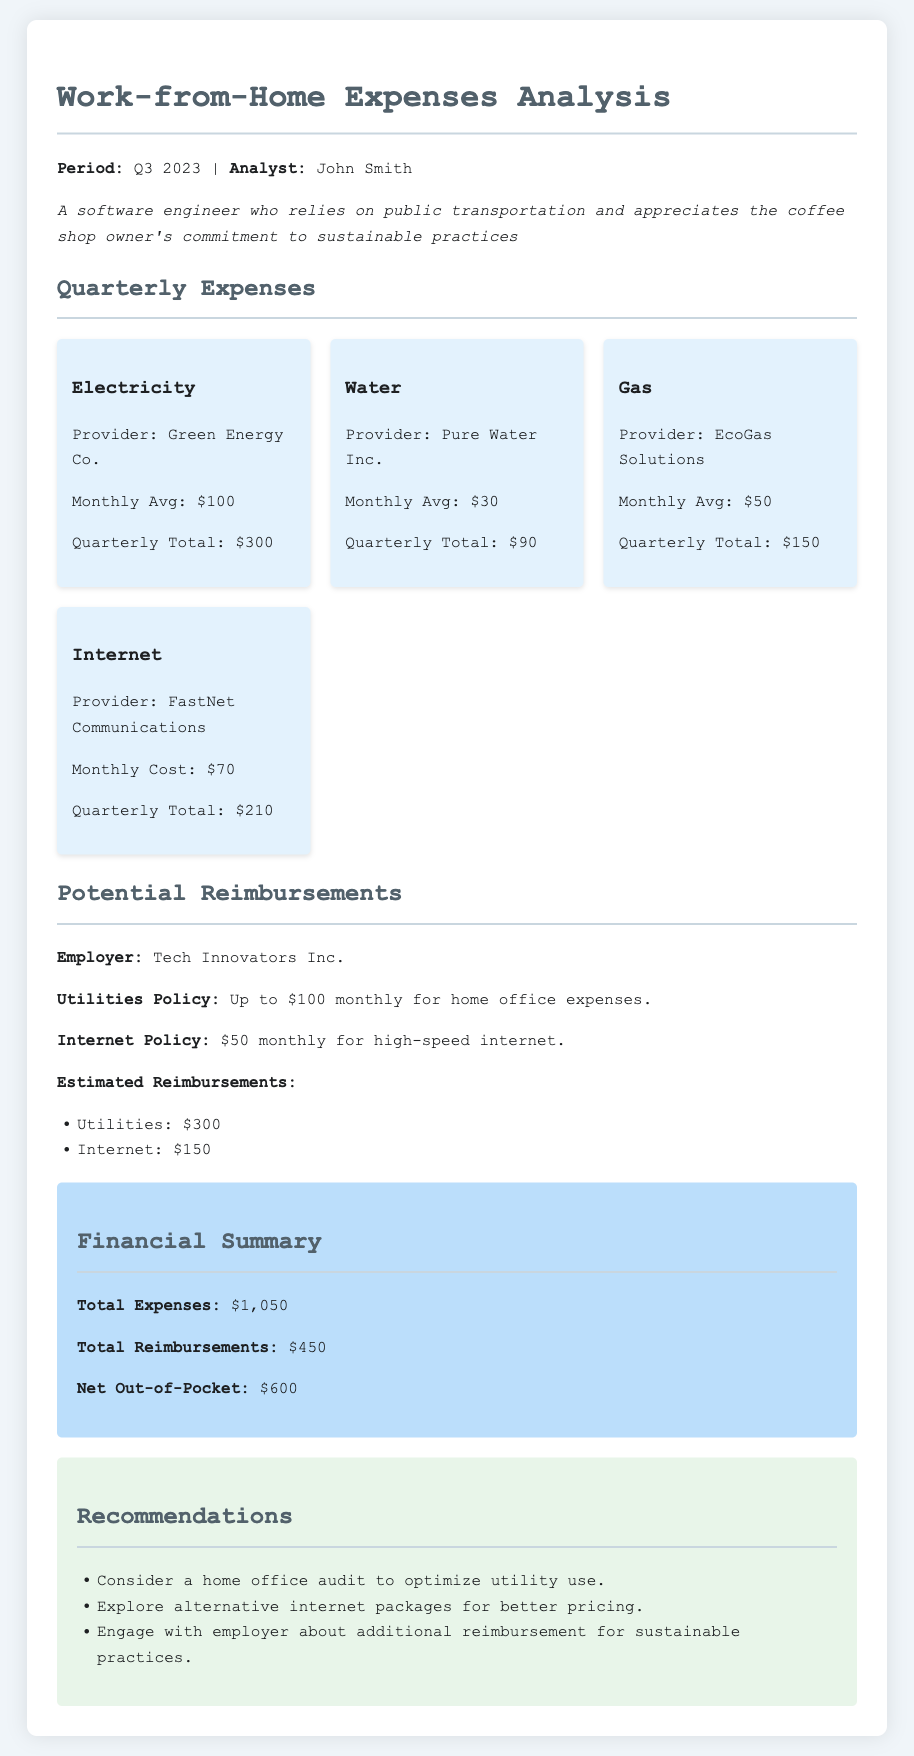What is the total quarterly electricity expense? The total quarterly electricity expense is given in the document as $300.
Answer: $300 Who is the internet provider? The document states that the internet provider is FastNet Communications.
Answer: FastNet Communications What is the estimated reimbursement for utilities? The document specifies the estimated reimbursement for utilities as $300.
Answer: $300 What is the total out-of-pocket expense? The net out-of-pocket expense is calculated as total expenses minus total reimbursements, which is $1,050 - $450 = $600.
Answer: $600 What is the monthly average cost of water? The document lists the monthly average cost of water as $30.
Answer: $30 What recommendation is given regarding the internet? The recommendation includes exploring alternative internet packages for better pricing.
Answer: Explore alternative internet packages for better pricing What is the policy for internet reimbursement? The internet policy states $50 monthly for high-speed internet.
Answer: $50 monthly for high-speed internet What is the quarterly total for gas? The quarterly total for gas is stated as $150.
Answer: $150 Who is the analyst of this report? The analyst mentioned in the document is John Smith.
Answer: John Smith 